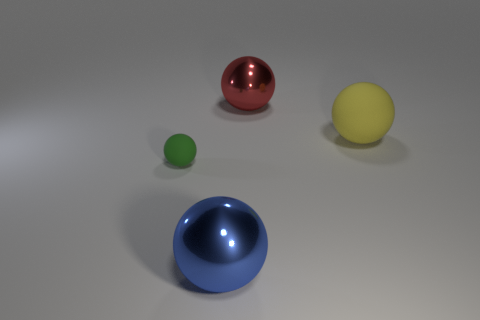There is a red object that is the same size as the blue ball; what is its shape?
Offer a very short reply. Sphere. There is a shiny thing that is left of the big red ball; does it have the same size as the object that is right of the large red thing?
Your answer should be compact. Yes. The other thing that is the same material as the large yellow object is what color?
Your response must be concise. Green. Do the large ball that is in front of the tiny green matte object and the sphere behind the yellow rubber thing have the same material?
Your response must be concise. Yes. Is there a metallic thing of the same size as the yellow rubber object?
Provide a short and direct response. Yes. What is the size of the matte ball that is in front of the large thing to the right of the red metal sphere?
Make the answer very short. Small. What is the shape of the big red shiny object behind the rubber thing on the left side of the big blue object?
Your answer should be compact. Sphere. How many tiny red blocks have the same material as the large red ball?
Offer a very short reply. 0. There is a large ball that is in front of the tiny green matte thing; what is it made of?
Make the answer very short. Metal. There is a small green thing behind the metallic sphere that is in front of the thing that is on the right side of the large red metal thing; what is its shape?
Keep it short and to the point. Sphere. 